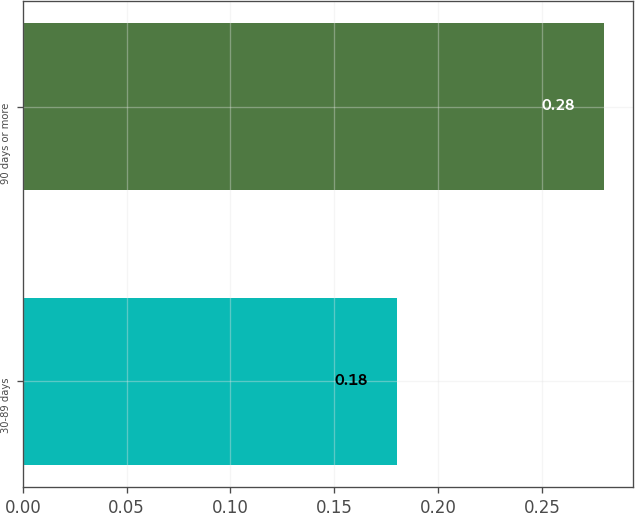Convert chart. <chart><loc_0><loc_0><loc_500><loc_500><bar_chart><fcel>30-89 days<fcel>90 days or more<nl><fcel>0.18<fcel>0.28<nl></chart> 